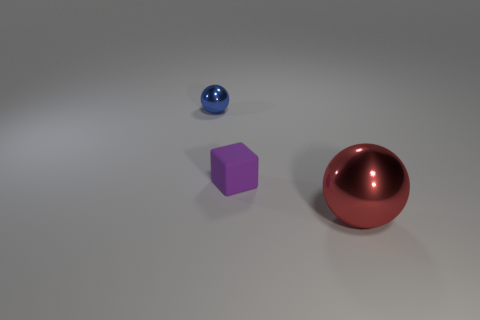Add 2 yellow metal spheres. How many objects exist? 5 Add 2 small blue balls. How many small blue balls are left? 3 Add 2 big green cylinders. How many big green cylinders exist? 2 Subtract 0 green cylinders. How many objects are left? 3 Subtract all cubes. How many objects are left? 2 Subtract all large balls. Subtract all tiny cubes. How many objects are left? 1 